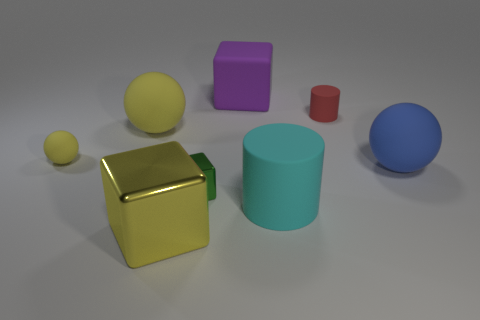Add 1 small red rubber blocks. How many objects exist? 9 Subtract all blocks. How many objects are left? 5 Add 6 tiny yellow matte balls. How many tiny yellow matte balls exist? 7 Subtract 0 cyan spheres. How many objects are left? 8 Subtract all tiny red things. Subtract all balls. How many objects are left? 4 Add 2 tiny red rubber things. How many tiny red rubber things are left? 3 